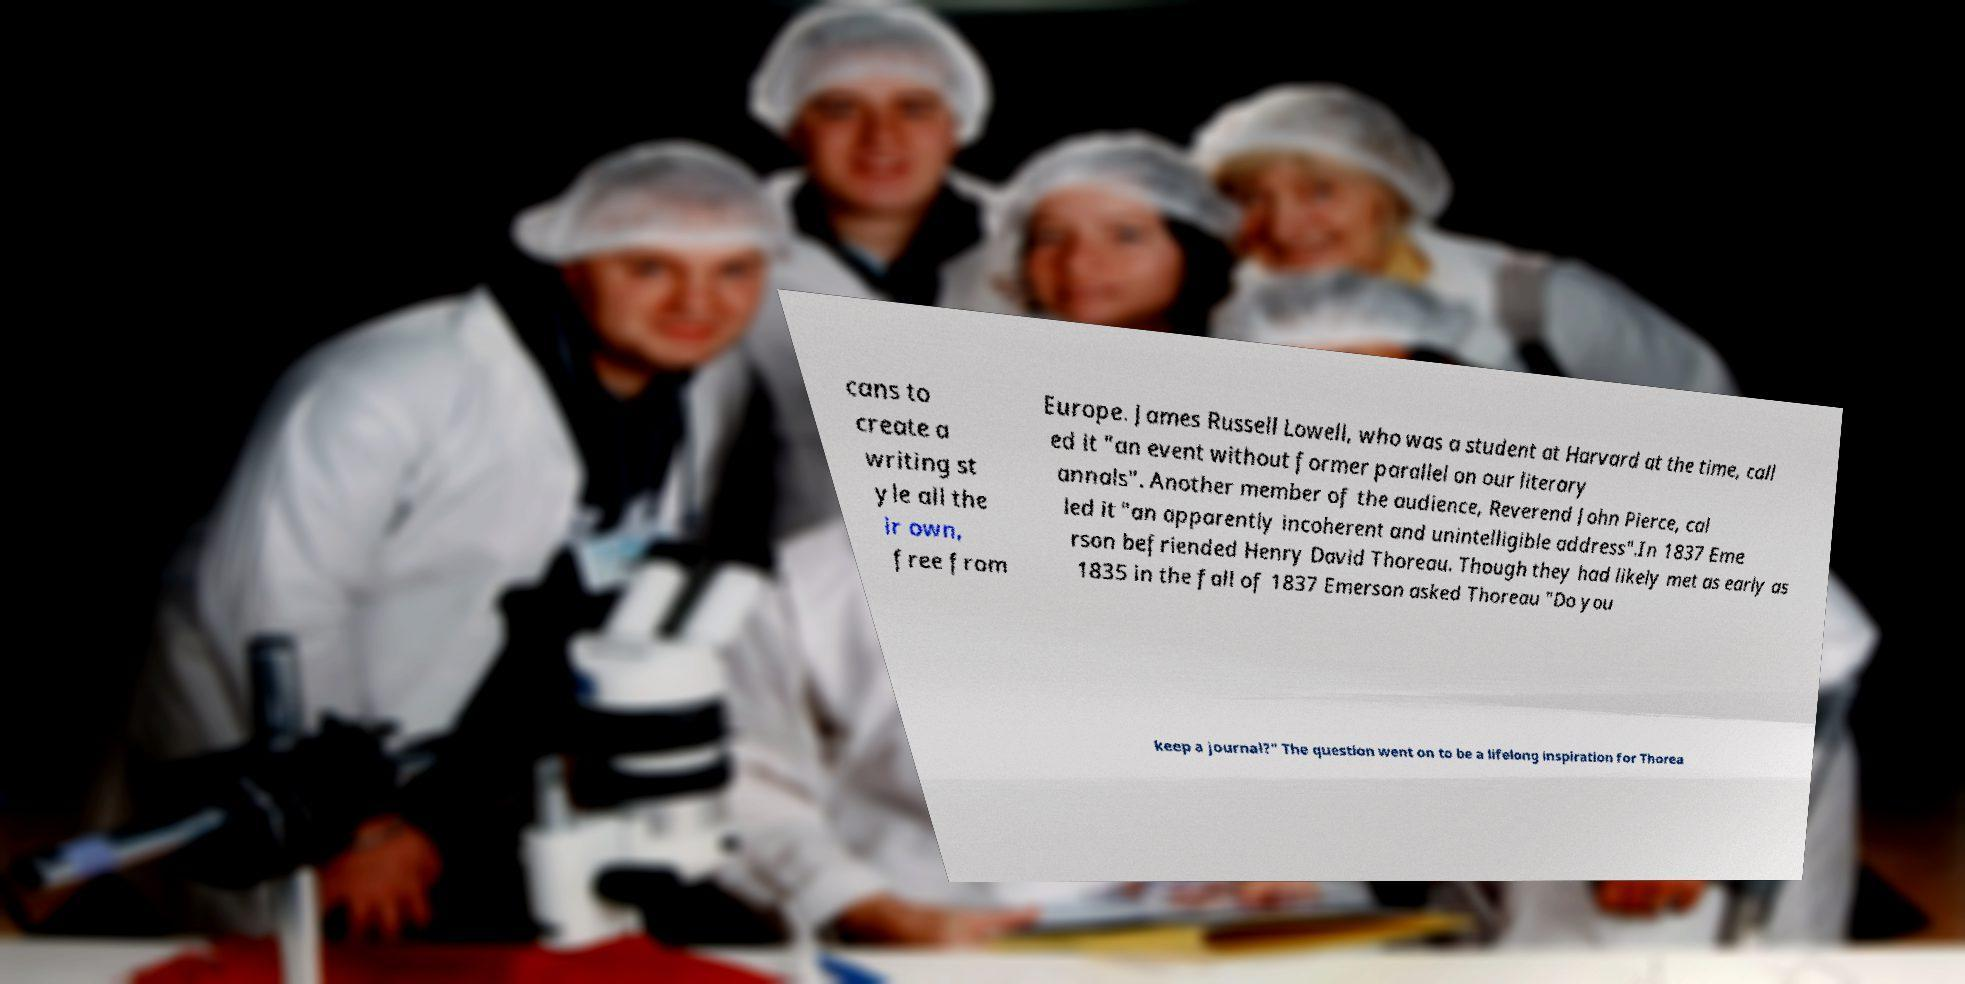For documentation purposes, I need the text within this image transcribed. Could you provide that? cans to create a writing st yle all the ir own, free from Europe. James Russell Lowell, who was a student at Harvard at the time, call ed it "an event without former parallel on our literary annals". Another member of the audience, Reverend John Pierce, cal led it "an apparently incoherent and unintelligible address".In 1837 Eme rson befriended Henry David Thoreau. Though they had likely met as early as 1835 in the fall of 1837 Emerson asked Thoreau "Do you keep a journal?" The question went on to be a lifelong inspiration for Thorea 